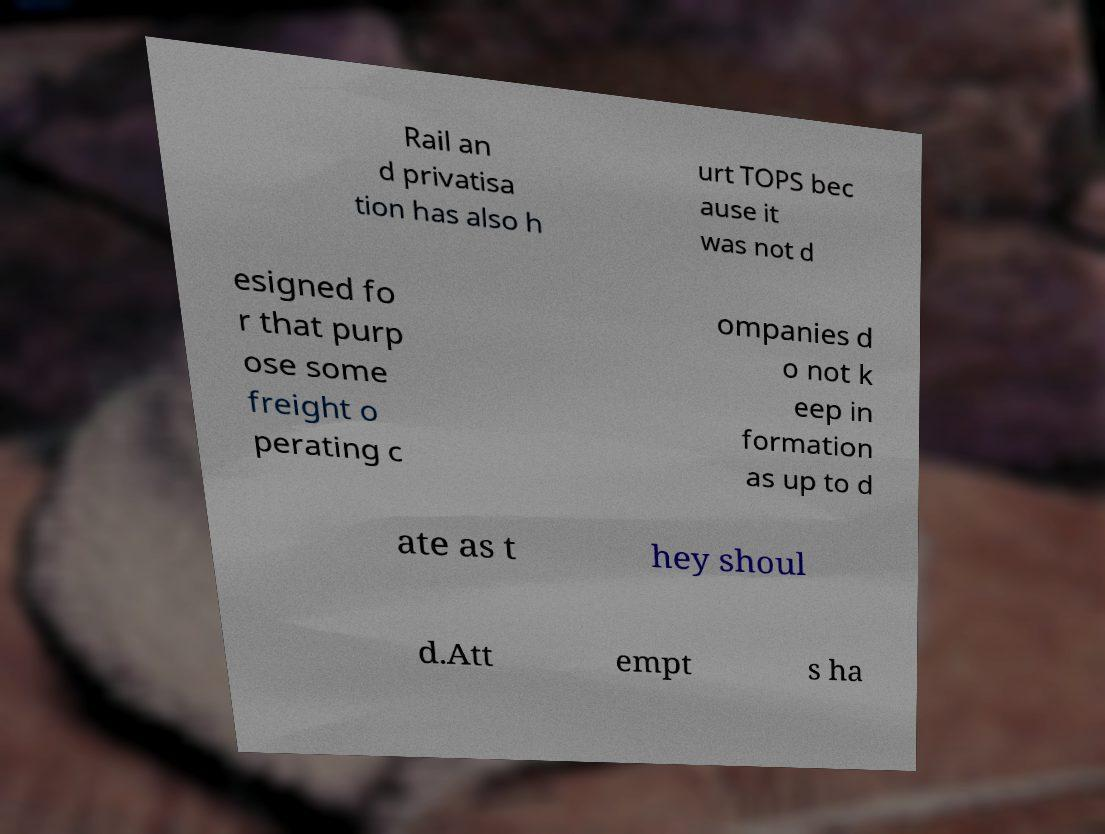Please identify and transcribe the text found in this image. Rail an d privatisa tion has also h urt TOPS bec ause it was not d esigned fo r that purp ose some freight o perating c ompanies d o not k eep in formation as up to d ate as t hey shoul d.Att empt s ha 